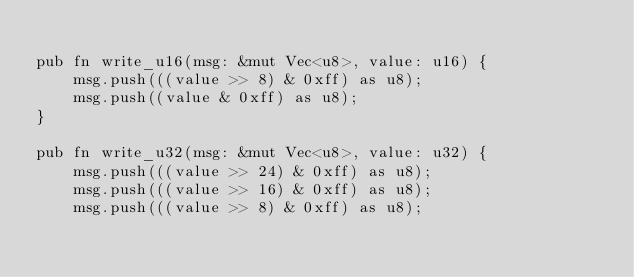<code> <loc_0><loc_0><loc_500><loc_500><_Rust_>
pub fn write_u16(msg: &mut Vec<u8>, value: u16) {
    msg.push(((value >> 8) & 0xff) as u8);
    msg.push((value & 0xff) as u8);
}

pub fn write_u32(msg: &mut Vec<u8>, value: u32) {
    msg.push(((value >> 24) & 0xff) as u8);
    msg.push(((value >> 16) & 0xff) as u8);
    msg.push(((value >> 8) & 0xff) as u8);</code> 